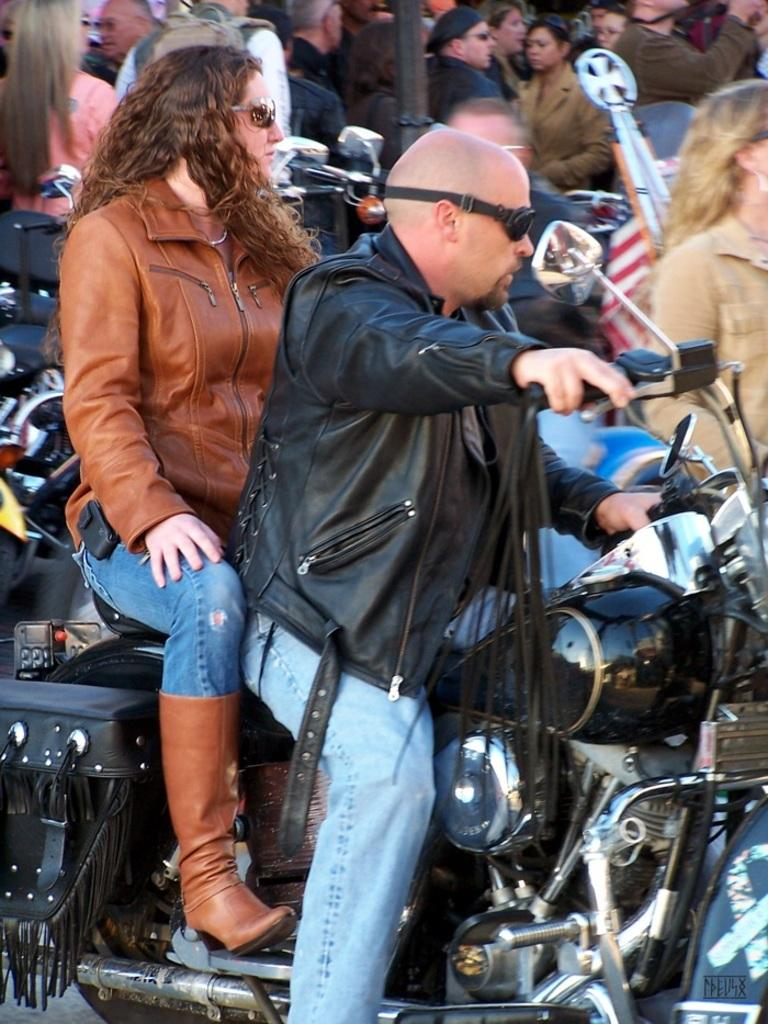Who are the people in the image? There is a woman and a man in the image. What are they doing in the image? The woman and the man are sitting on a motorbike. What can be observed about their appearance? Both the woman and the man are wearing spectacles. What is happening in the background of the image? There are people standing in the background of the image. What type of silk is the woman wearing in the image? There is no silk visible in the image; the woman is wearing spectacles and sitting on a motorbike. What kind of meat is the man holding in the image? There is there any meat present in the image? 